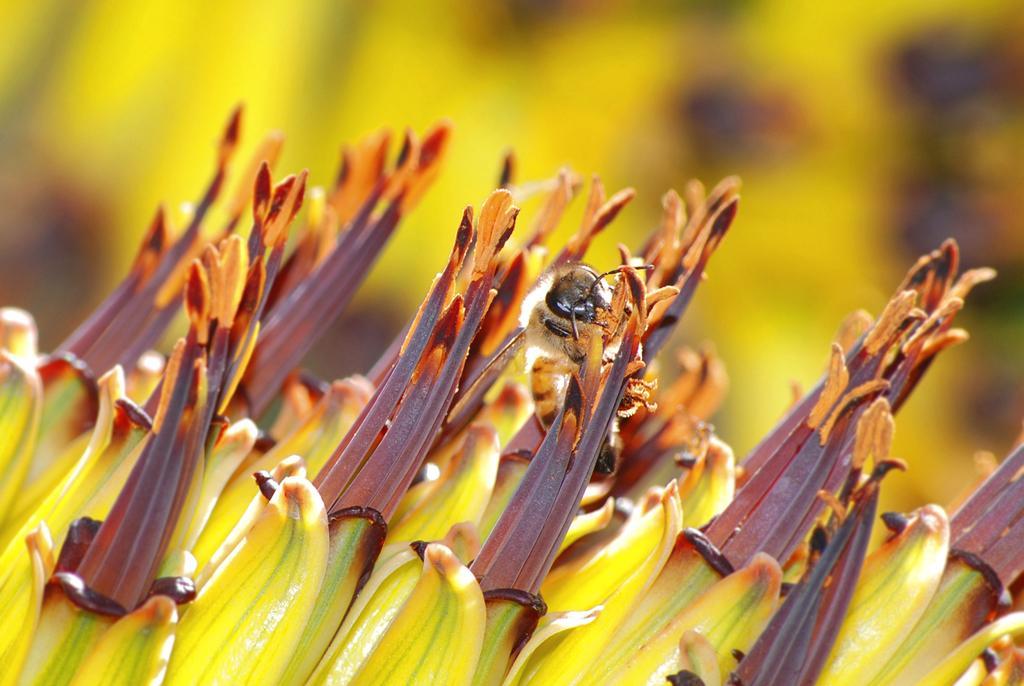In one or two sentences, can you explain what this image depicts? In this image we can see an insect on the flower and the background is blurred. 